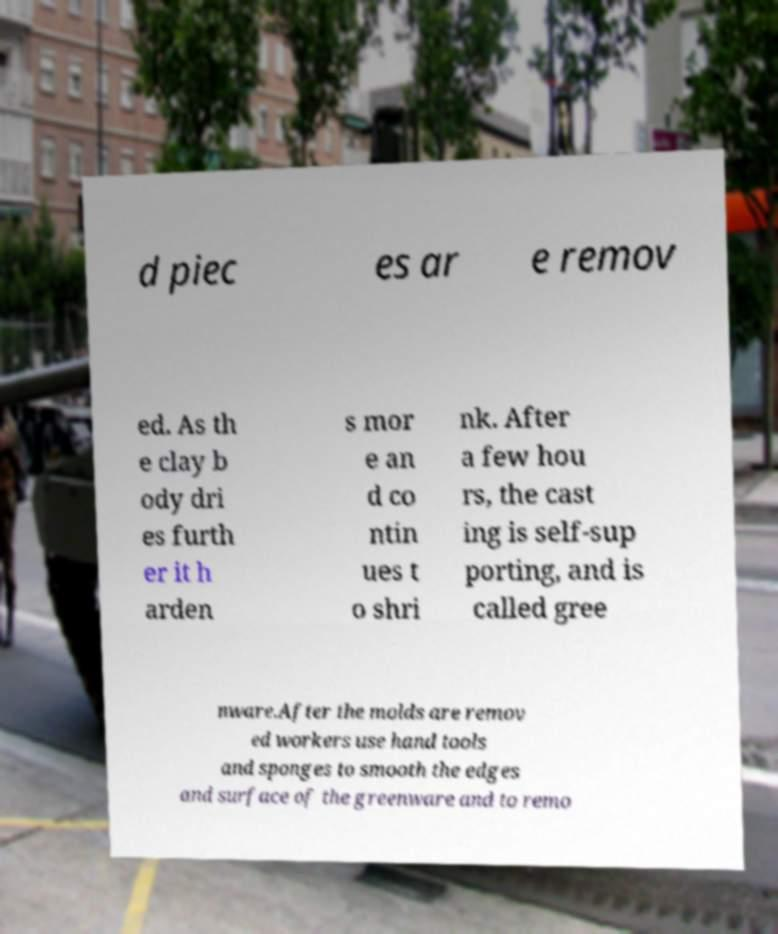Please read and relay the text visible in this image. What does it say? d piec es ar e remov ed. As th e clay b ody dri es furth er it h arden s mor e an d co ntin ues t o shri nk. After a few hou rs, the cast ing is self-sup porting, and is called gree nware.After the molds are remov ed workers use hand tools and sponges to smooth the edges and surface of the greenware and to remo 